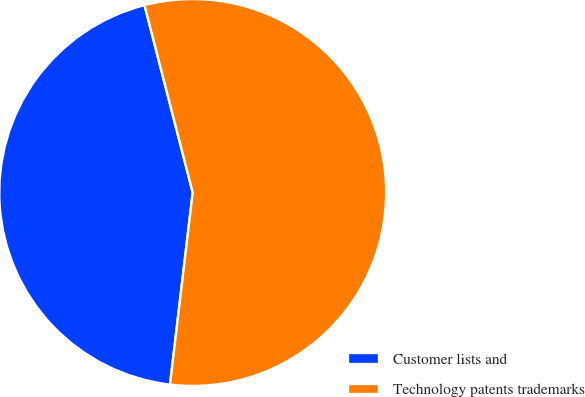<chart> <loc_0><loc_0><loc_500><loc_500><pie_chart><fcel>Customer lists and<fcel>Technology patents trademarks<nl><fcel>44.12%<fcel>55.88%<nl></chart> 